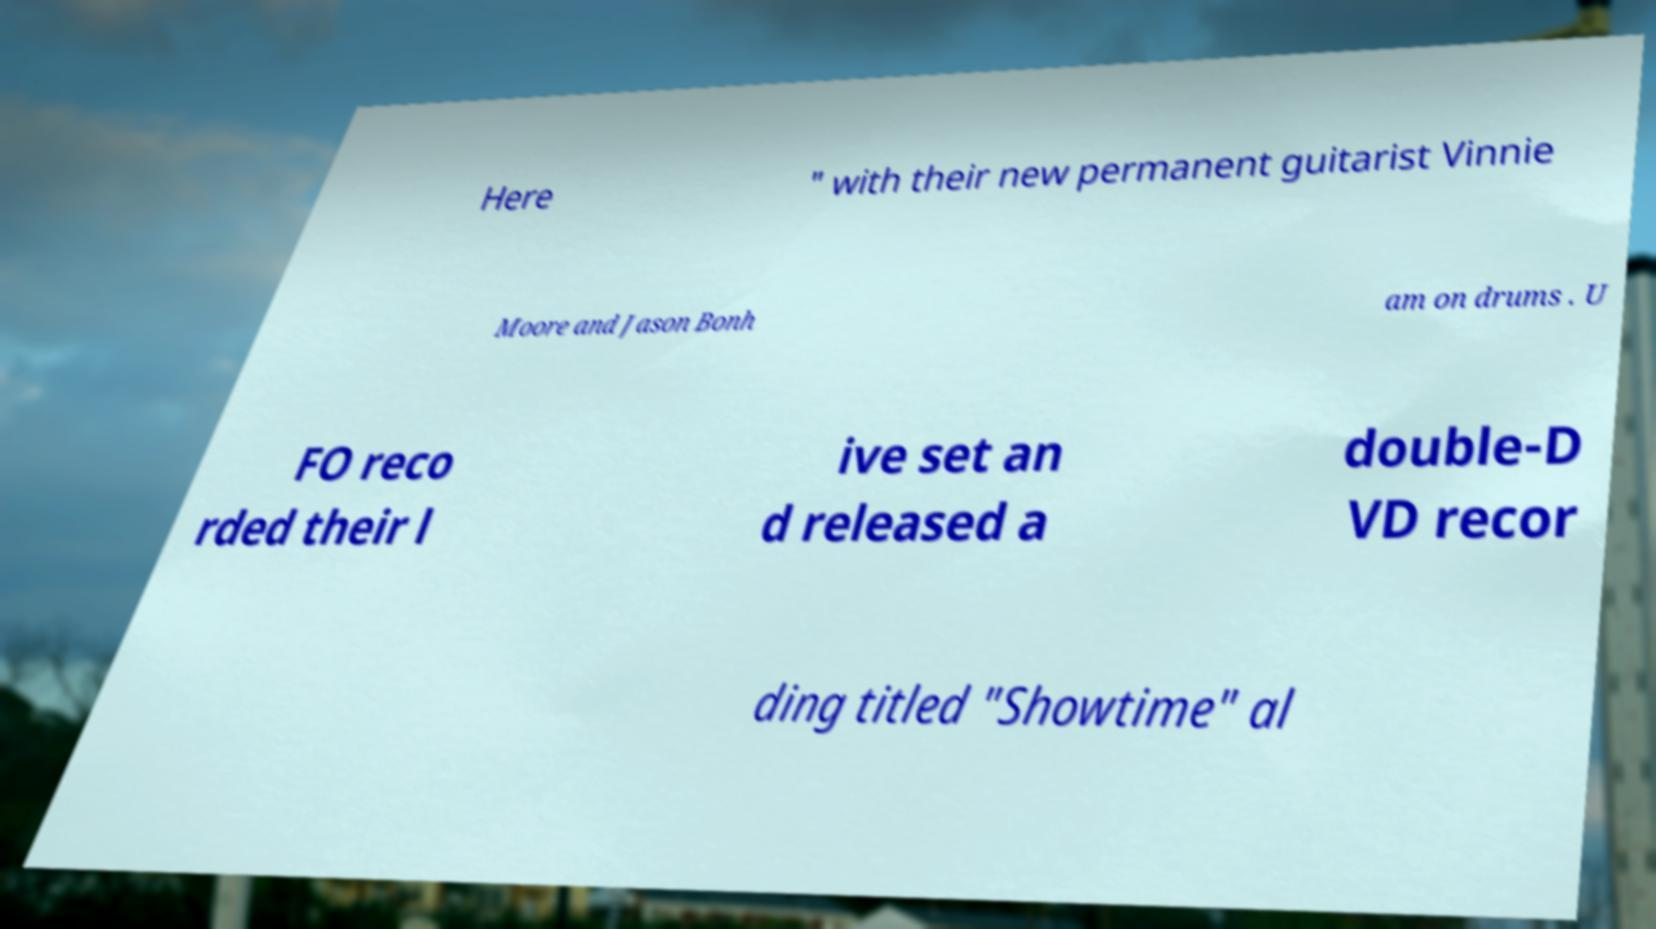Can you accurately transcribe the text from the provided image for me? Here " with their new permanent guitarist Vinnie Moore and Jason Bonh am on drums . U FO reco rded their l ive set an d released a double-D VD recor ding titled "Showtime" al 